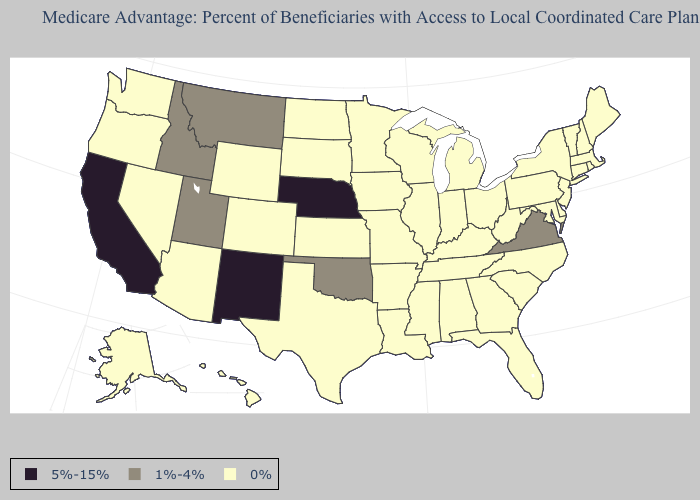Which states hav the highest value in the MidWest?
Short answer required. Nebraska. What is the value of Rhode Island?
Keep it brief. 0%. What is the highest value in states that border Georgia?
Be succinct. 0%. What is the value of Texas?
Give a very brief answer. 0%. Which states have the highest value in the USA?
Answer briefly. California, Nebraska, New Mexico. Among the states that border Oklahoma , does New Mexico have the lowest value?
Short answer required. No. What is the value of Ohio?
Be succinct. 0%. Does Kansas have the same value as Nebraska?
Answer briefly. No. Does Delaware have the lowest value in the USA?
Give a very brief answer. Yes. Which states have the highest value in the USA?
Be succinct. California, Nebraska, New Mexico. Name the states that have a value in the range 5%-15%?
Concise answer only. California, Nebraska, New Mexico. Name the states that have a value in the range 5%-15%?
Keep it brief. California, Nebraska, New Mexico. What is the highest value in the MidWest ?
Short answer required. 5%-15%. 